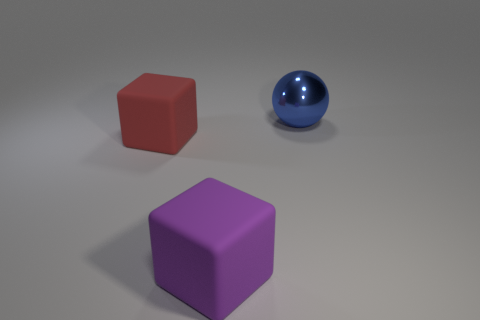Is there any other thing that has the same material as the blue object?
Ensure brevity in your answer.  No. Do the purple rubber object and the large thing that is behind the big red block have the same shape?
Keep it short and to the point. No. What material is the large purple block?
Keep it short and to the point. Rubber. What color is the object behind the matte thing behind the big cube right of the large red matte block?
Your response must be concise. Blue. How many purple cubes have the same size as the metallic thing?
Provide a short and direct response. 1. How many large rubber objects are there?
Ensure brevity in your answer.  2. Do the big red object and the thing that is in front of the red thing have the same material?
Ensure brevity in your answer.  Yes. How many purple objects are large cubes or shiny cylinders?
Your response must be concise. 1. What size is the red block that is the same material as the purple block?
Make the answer very short. Large. How many other big rubber things are the same shape as the red thing?
Provide a short and direct response. 1. 